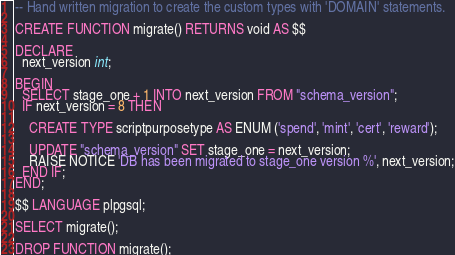Convert code to text. <code><loc_0><loc_0><loc_500><loc_500><_SQL_>-- Hand written migration to create the custom types with 'DOMAIN' statements.

CREATE FUNCTION migrate() RETURNS void AS $$

DECLARE
  next_version int;

BEGIN
  SELECT stage_one + 1 INTO next_version FROM "schema_version";
  IF next_version = 8 THEN

    CREATE TYPE scriptpurposetype AS ENUM ('spend', 'mint', 'cert', 'reward');

    UPDATE "schema_version" SET stage_one = next_version;
    RAISE NOTICE 'DB has been migrated to stage_one version %', next_version;
  END IF;
END;

$$ LANGUAGE plpgsql;

SELECT migrate();

DROP FUNCTION migrate();
</code> 